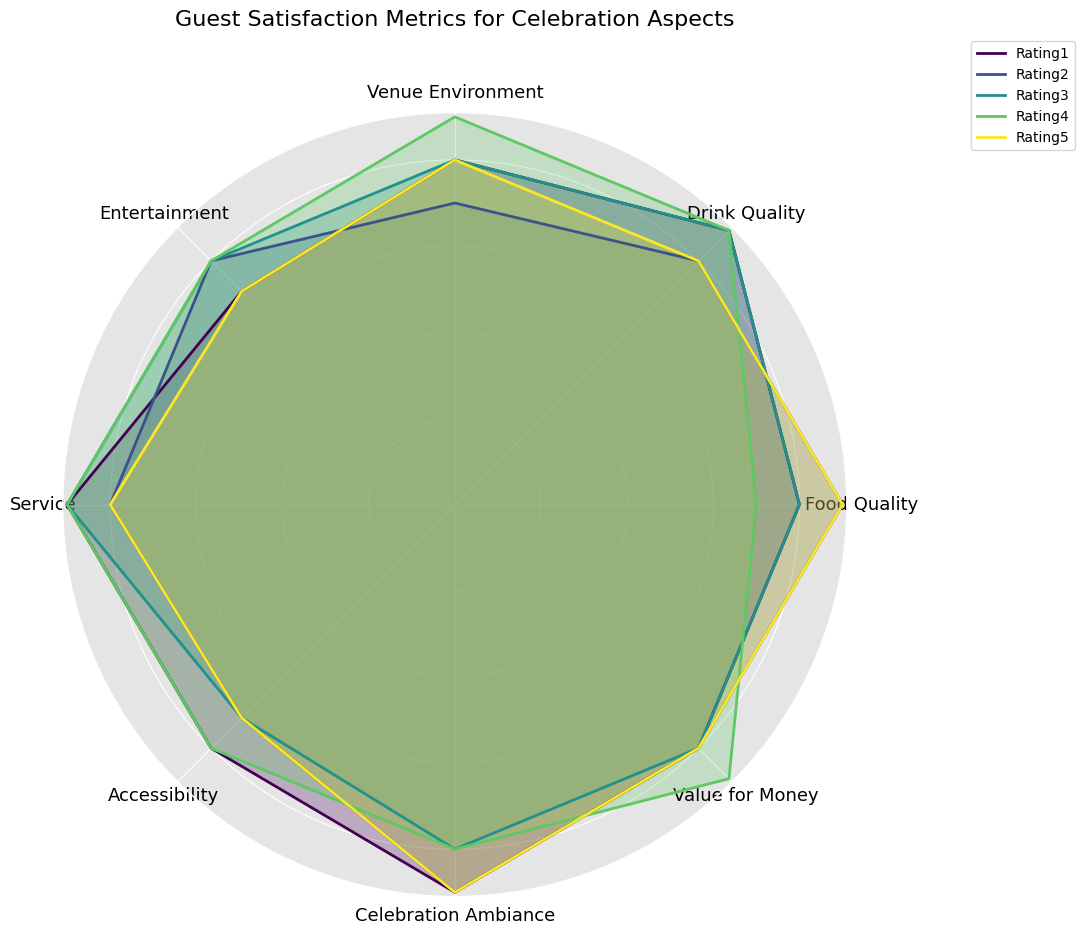What's the highest rating given to the 'Food Quality' aspect? Look at the 'Food Quality' ratings in the radar chart and find the highest value among them.
Answer: 9 Which celebration aspect had the lowest rating across all metrics? Identify the aspect with the lowest single value across all metrics in the radar chart.
Answer: Accessibility How does the 'Drink Quality' compare to 'Service' in terms of average rating? Calculate the average rating for both 'Drink Quality' and 'Service' by summing their ratings and dividing by the number of metrics, then compare them. Drink Quality = (9+8+9+9+8)/5 = 8.6; Service = (9+8+9+9+8)/5 = 8.6
Answer: Equal Which aspect consistently received the highest ratings? Identify the aspect that has the highest average or multiple high ratings in the radar chart.
Answer: Celebration Ambiance Is the rating for 'Entertainment' higher than 'Venue Environment' in more than half of the metrics? Compare the ratings for 'Entertainment' and 'Venue Environment' across all metrics and count how many times 'Entertainment' is higher. Entertainment ratings: 7, 8, 8, 8, 7. Venue Environment ratings: 8, 7, 8, 9, 8. Entertainment > Venue Environment in 2/5 metrics.
Answer: No Which aspect is rated highest on average, excluding any ties? Calculate the average rating for each aspect and compare them to find the highest. Food Quality = (8+9+8+7+9)/5 = 8.2; Drink Quality = (9+8+9+9+8)/5 = 8.6; Venue Environment = (8+7+8+9+8)/5 = 8.0; Entertainment = (7+8+8+8+7)/5 = 7.6; Service = (9+8+9+9+8)/5 = 8.6; Accessibility = (8+7+7+8+7)/5 = 7.4; Celebration Ambiance = (9+9+8+8+9)/5 = 8.6; Value for Money = (8+8+8+9+8)/5 = 8.2. Highest average rating: Drink Quality, Service, Celebration Ambiance = 8.6. Excluding ties, none.
Answer: None What's the difference between the highest and lowest ratings for 'Value for Money'? Identify the highest and lowest ratings for 'Value for Money' and subtract the lowest from the highest. Ratings: 8, 8, 8, 9, 8; Highest = 9, Lowest = 8. Difference = 9 - 8
Answer: 1 Which aspect has the highest variance in ratings? Calculate the variance for each aspect by finding the average of the squared differences from the mean. Compare these variances to identify the highest.
Answer: 'Food Quality' has the highest variance Are there any aspects where the ratings are constant across all metrics? Identify any aspect where all the ratings are the same value.
Answer: No What's the combined total rating for 'Celebration Ambiance' across all metrics? Sum up all the ratings for 'Celebration Ambiance'. Ratings: 9, 9, 8, 8, 9. Combined total = 9 + 9 + 8 + 8 + 9
Answer: 43 